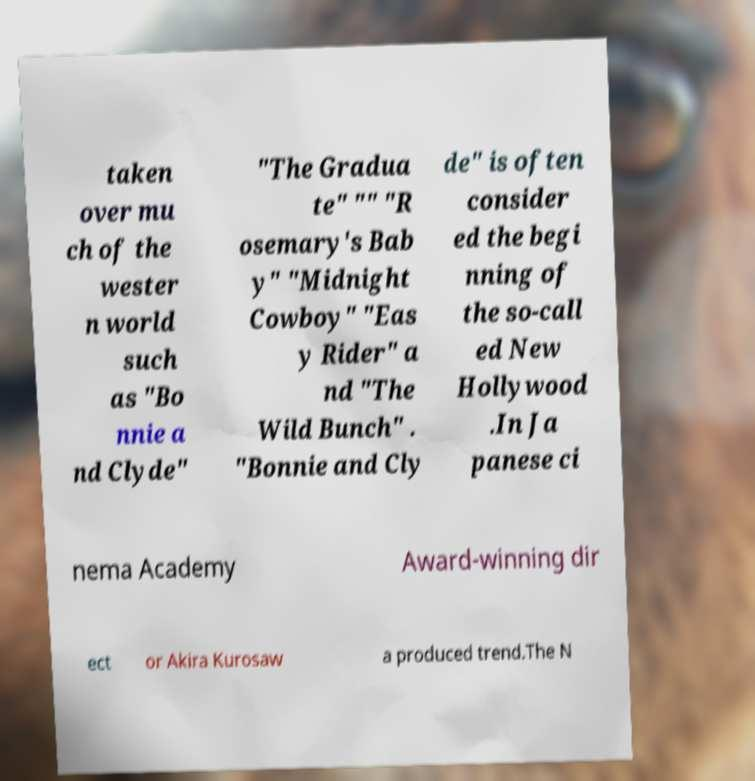Could you extract and type out the text from this image? taken over mu ch of the wester n world such as "Bo nnie a nd Clyde" "The Gradua te" "" "R osemary's Bab y" "Midnight Cowboy" "Eas y Rider" a nd "The Wild Bunch" . "Bonnie and Cly de" is often consider ed the begi nning of the so-call ed New Hollywood .In Ja panese ci nema Academy Award-winning dir ect or Akira Kurosaw a produced trend.The N 